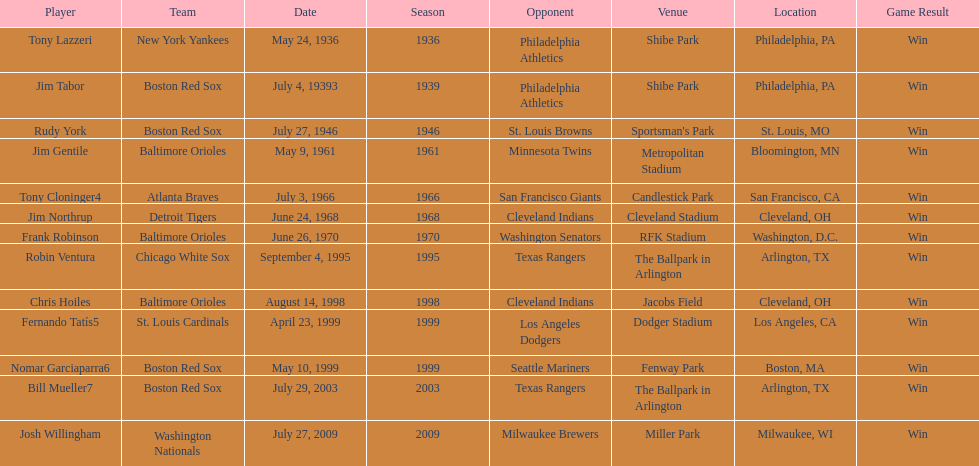What was the name of the last person to accomplish this up to date? Josh Willingham. 